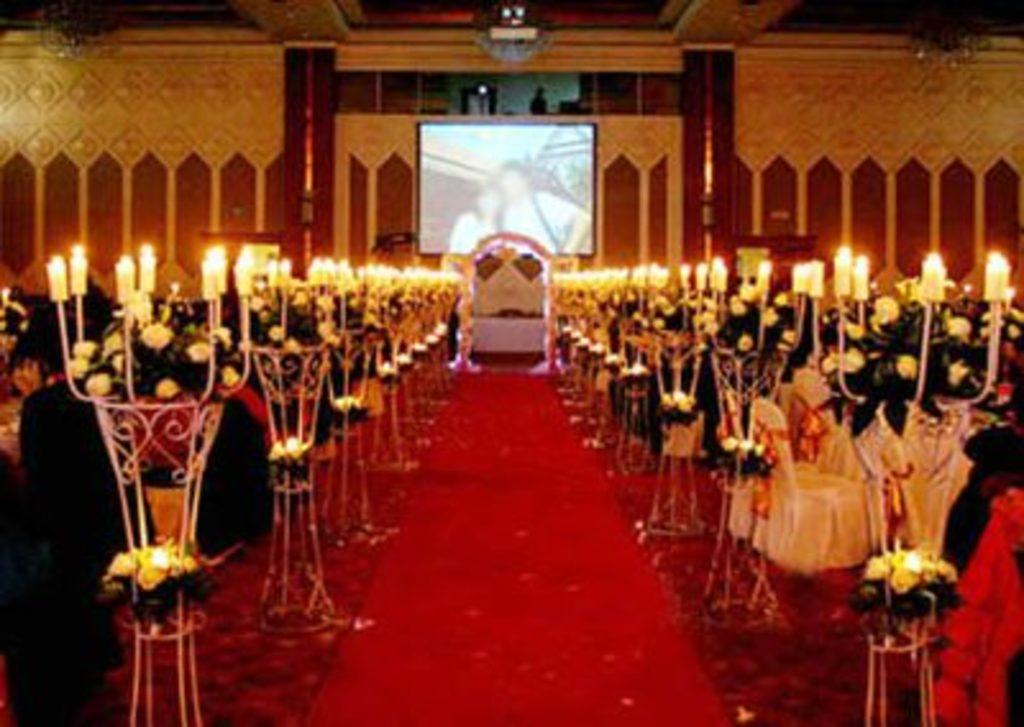What is burning in the image? There are candles with fire in the image. What type of flooring is visible in the image? There is a red color carpet in the image. What can be seen in the background of the image? There is a projector screen, a wall, flowers, and other objects in the background of the image. How does the slave help with the candles in the image? There is no slave present in the image, and therefore no such assistance can be observed. What type of writing is visible on the projector screen in the image? There is no writing visible on the projector screen in the image; it is it is a blank screen. 